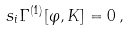<formula> <loc_0><loc_0><loc_500><loc_500>s _ { i } \Gamma ^ { ( 1 ) } [ \varphi , K ] = 0 \, ,</formula> 